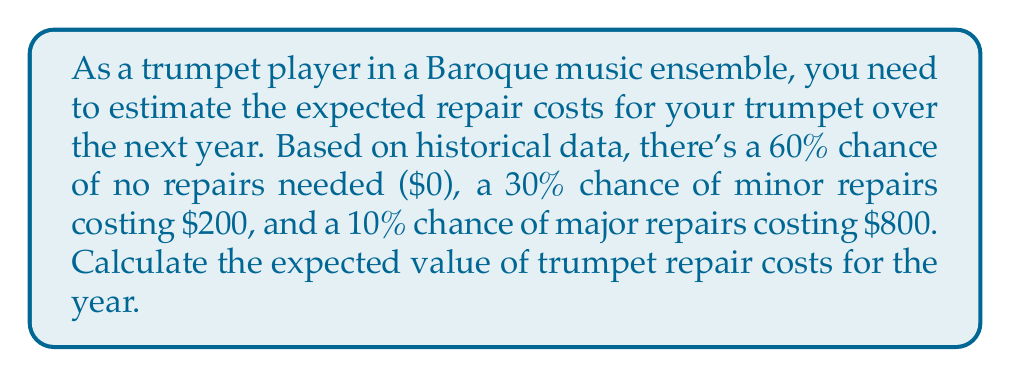Solve this math problem. To calculate the expected value, we need to multiply each possible outcome by its probability and then sum these products. Let's break it down step-by-step:

1. Define the probabilities and costs:
   - No repairs: $P(0) = 0.60$, Cost = $0
   - Minor repairs: $P(200) = 0.30$, Cost = $200
   - Major repairs: $P(800) = 0.10$, Cost = $800

2. Calculate the expected value using the formula:
   $$E(X) = \sum_{i=1}^{n} x_i \cdot P(x_i)$$

   Where $x_i$ is the cost and $P(x_i)$ is the probability of that cost.

3. Plug in the values:
   $$E(X) = (0 \cdot 0.60) + (200 \cdot 0.30) + (800 \cdot 0.10)$$

4. Perform the calculations:
   $$E(X) = 0 + 60 + 80 = 140$$

Therefore, the expected value of trumpet repair costs for the year is $140.
Answer: $140 